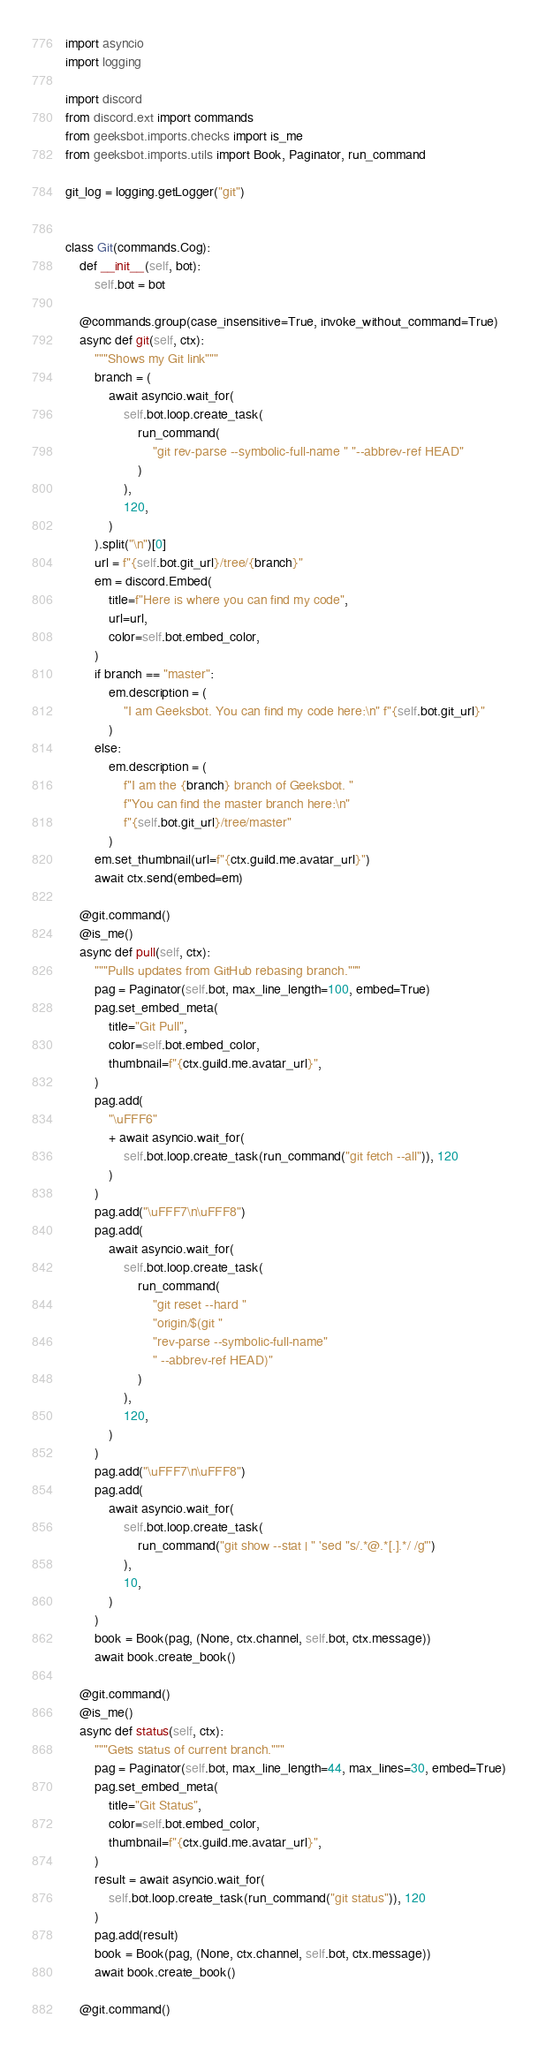Convert code to text. <code><loc_0><loc_0><loc_500><loc_500><_Python_>import asyncio
import logging

import discord
from discord.ext import commands
from geeksbot.imports.checks import is_me
from geeksbot.imports.utils import Book, Paginator, run_command

git_log = logging.getLogger("git")


class Git(commands.Cog):
    def __init__(self, bot):
        self.bot = bot

    @commands.group(case_insensitive=True, invoke_without_command=True)
    async def git(self, ctx):
        """Shows my Git link"""
        branch = (
            await asyncio.wait_for(
                self.bot.loop.create_task(
                    run_command(
                        "git rev-parse --symbolic-full-name " "--abbrev-ref HEAD"
                    )
                ),
                120,
            )
        ).split("\n")[0]
        url = f"{self.bot.git_url}/tree/{branch}"
        em = discord.Embed(
            title=f"Here is where you can find my code",
            url=url,
            color=self.bot.embed_color,
        )
        if branch == "master":
            em.description = (
                "I am Geeksbot. You can find my code here:\n" f"{self.bot.git_url}"
            )
        else:
            em.description = (
                f"I am the {branch} branch of Geeksbot. "
                f"You can find the master branch here:\n"
                f"{self.bot.git_url}/tree/master"
            )
        em.set_thumbnail(url=f"{ctx.guild.me.avatar_url}")
        await ctx.send(embed=em)

    @git.command()
    @is_me()
    async def pull(self, ctx):
        """Pulls updates from GitHub rebasing branch."""
        pag = Paginator(self.bot, max_line_length=100, embed=True)
        pag.set_embed_meta(
            title="Git Pull",
            color=self.bot.embed_color,
            thumbnail=f"{ctx.guild.me.avatar_url}",
        )
        pag.add(
            "\uFFF6"
            + await asyncio.wait_for(
                self.bot.loop.create_task(run_command("git fetch --all")), 120
            )
        )
        pag.add("\uFFF7\n\uFFF8")
        pag.add(
            await asyncio.wait_for(
                self.bot.loop.create_task(
                    run_command(
                        "git reset --hard "
                        "origin/$(git "
                        "rev-parse --symbolic-full-name"
                        " --abbrev-ref HEAD)"
                    )
                ),
                120,
            )
        )
        pag.add("\uFFF7\n\uFFF8")
        pag.add(
            await asyncio.wait_for(
                self.bot.loop.create_task(
                    run_command("git show --stat | " 'sed "s/.*@.*[.].*/ /g"')
                ),
                10,
            )
        )
        book = Book(pag, (None, ctx.channel, self.bot, ctx.message))
        await book.create_book()

    @git.command()
    @is_me()
    async def status(self, ctx):
        """Gets status of current branch."""
        pag = Paginator(self.bot, max_line_length=44, max_lines=30, embed=True)
        pag.set_embed_meta(
            title="Git Status",
            color=self.bot.embed_color,
            thumbnail=f"{ctx.guild.me.avatar_url}",
        )
        result = await asyncio.wait_for(
            self.bot.loop.create_task(run_command("git status")), 120
        )
        pag.add(result)
        book = Book(pag, (None, ctx.channel, self.bot, ctx.message))
        await book.create_book()

    @git.command()</code> 